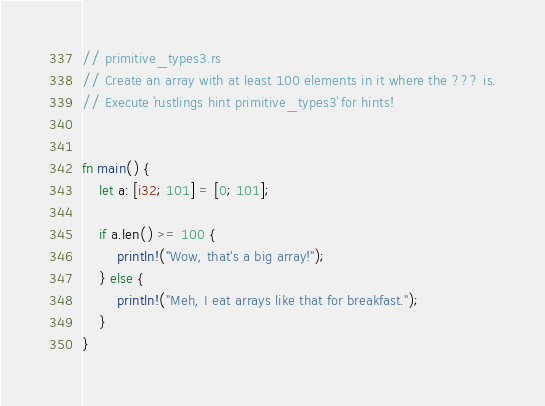<code> <loc_0><loc_0><loc_500><loc_500><_Rust_>// primitive_types3.rs
// Create an array with at least 100 elements in it where the ??? is.
// Execute `rustlings hint primitive_types3` for hints!


fn main() {
    let a: [i32; 101] = [0; 101];

    if a.len() >= 100 {
        println!("Wow, that's a big array!");
    } else {
        println!("Meh, I eat arrays like that for breakfast.");
    }
}
</code> 